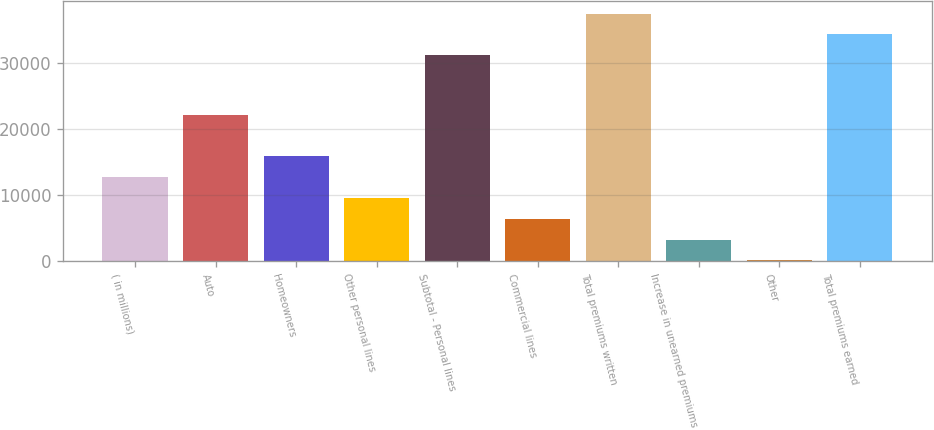Convert chart to OTSL. <chart><loc_0><loc_0><loc_500><loc_500><bar_chart><fcel>( in millions)<fcel>Auto<fcel>Homeowners<fcel>Other personal lines<fcel>Subtotal - Personal lines<fcel>Commercial lines<fcel>Total premiums written<fcel>Increase in unearned premiums<fcel>Other<fcel>Total premiums earned<nl><fcel>12685<fcel>22042<fcel>15845.5<fcel>9524.5<fcel>31160<fcel>6364<fcel>37481<fcel>3203.5<fcel>43<fcel>34320.5<nl></chart> 